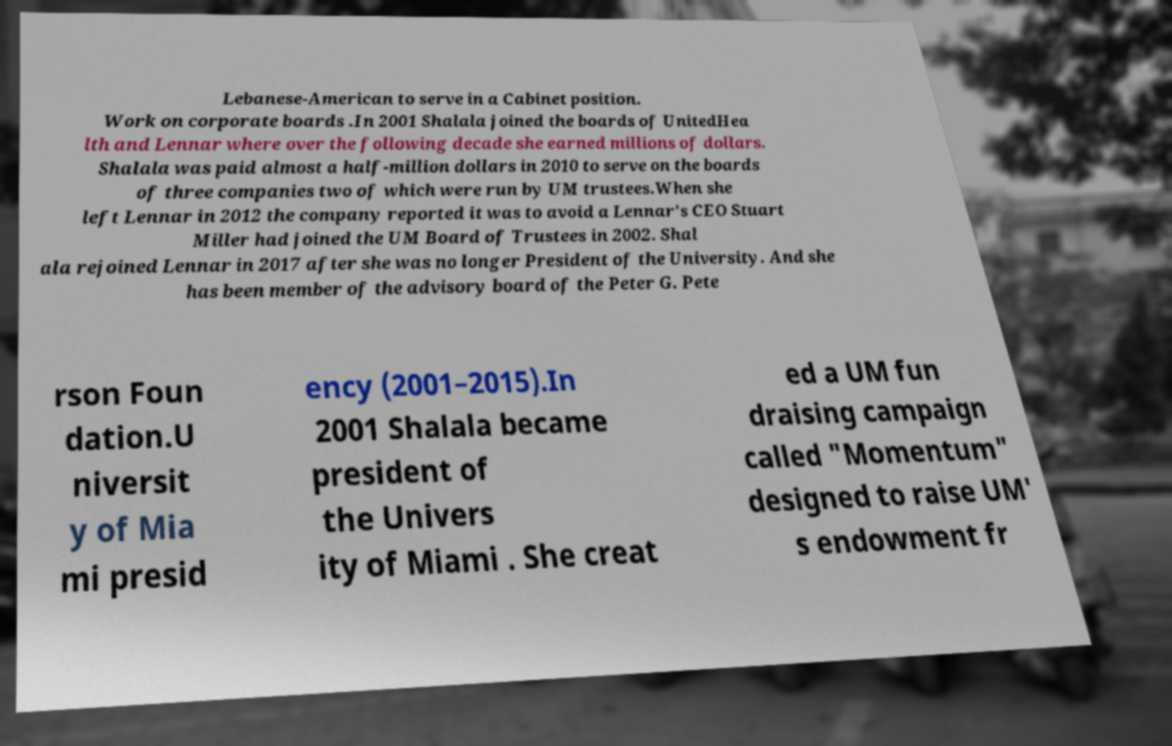Could you assist in decoding the text presented in this image and type it out clearly? Lebanese-American to serve in a Cabinet position. Work on corporate boards .In 2001 Shalala joined the boards of UnitedHea lth and Lennar where over the following decade she earned millions of dollars. Shalala was paid almost a half-million dollars in 2010 to serve on the boards of three companies two of which were run by UM trustees.When she left Lennar in 2012 the company reported it was to avoid a Lennar's CEO Stuart Miller had joined the UM Board of Trustees in 2002. Shal ala rejoined Lennar in 2017 after she was no longer President of the University. And she has been member of the advisory board of the Peter G. Pete rson Foun dation.U niversit y of Mia mi presid ency (2001–2015).In 2001 Shalala became president of the Univers ity of Miami . She creat ed a UM fun draising campaign called "Momentum" designed to raise UM' s endowment fr 